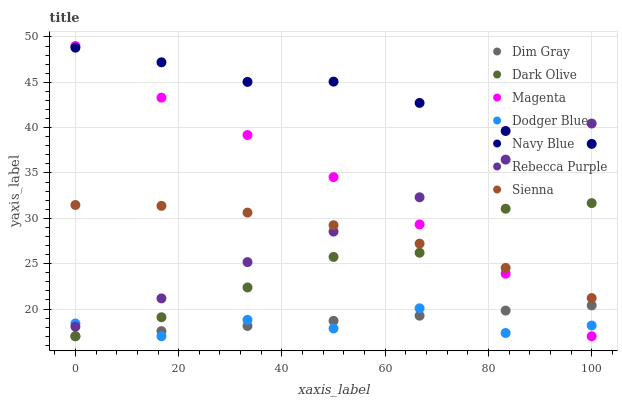Does Dodger Blue have the minimum area under the curve?
Answer yes or no. Yes. Does Navy Blue have the maximum area under the curve?
Answer yes or no. Yes. Does Dark Olive have the minimum area under the curve?
Answer yes or no. No. Does Dark Olive have the maximum area under the curve?
Answer yes or no. No. Is Dim Gray the smoothest?
Answer yes or no. Yes. Is Dodger Blue the roughest?
Answer yes or no. Yes. Is Navy Blue the smoothest?
Answer yes or no. No. Is Navy Blue the roughest?
Answer yes or no. No. Does Dim Gray have the lowest value?
Answer yes or no. Yes. Does Navy Blue have the lowest value?
Answer yes or no. No. Does Magenta have the highest value?
Answer yes or no. Yes. Does Navy Blue have the highest value?
Answer yes or no. No. Is Dark Olive less than Navy Blue?
Answer yes or no. Yes. Is Sienna greater than Dim Gray?
Answer yes or no. Yes. Does Magenta intersect Dim Gray?
Answer yes or no. Yes. Is Magenta less than Dim Gray?
Answer yes or no. No. Is Magenta greater than Dim Gray?
Answer yes or no. No. Does Dark Olive intersect Navy Blue?
Answer yes or no. No. 